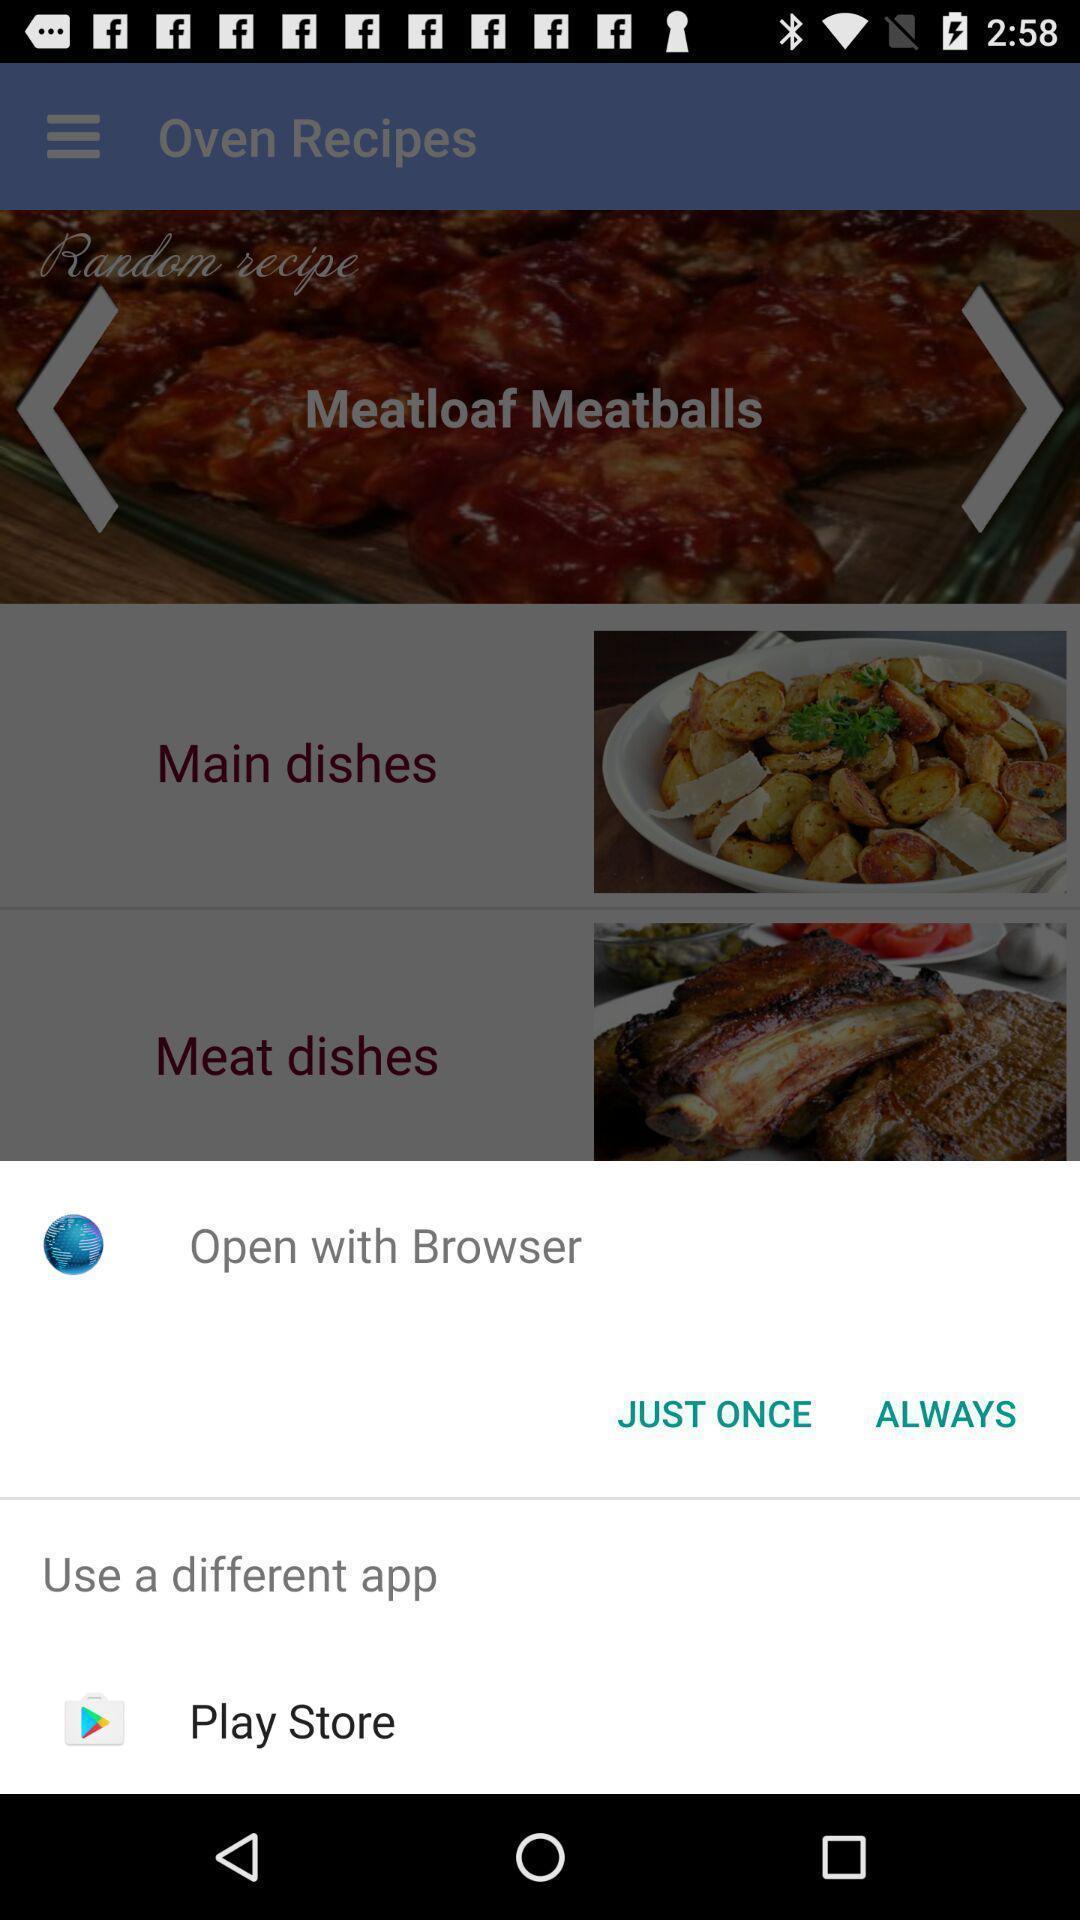Describe this image in words. Push up page showing app preference to open. 